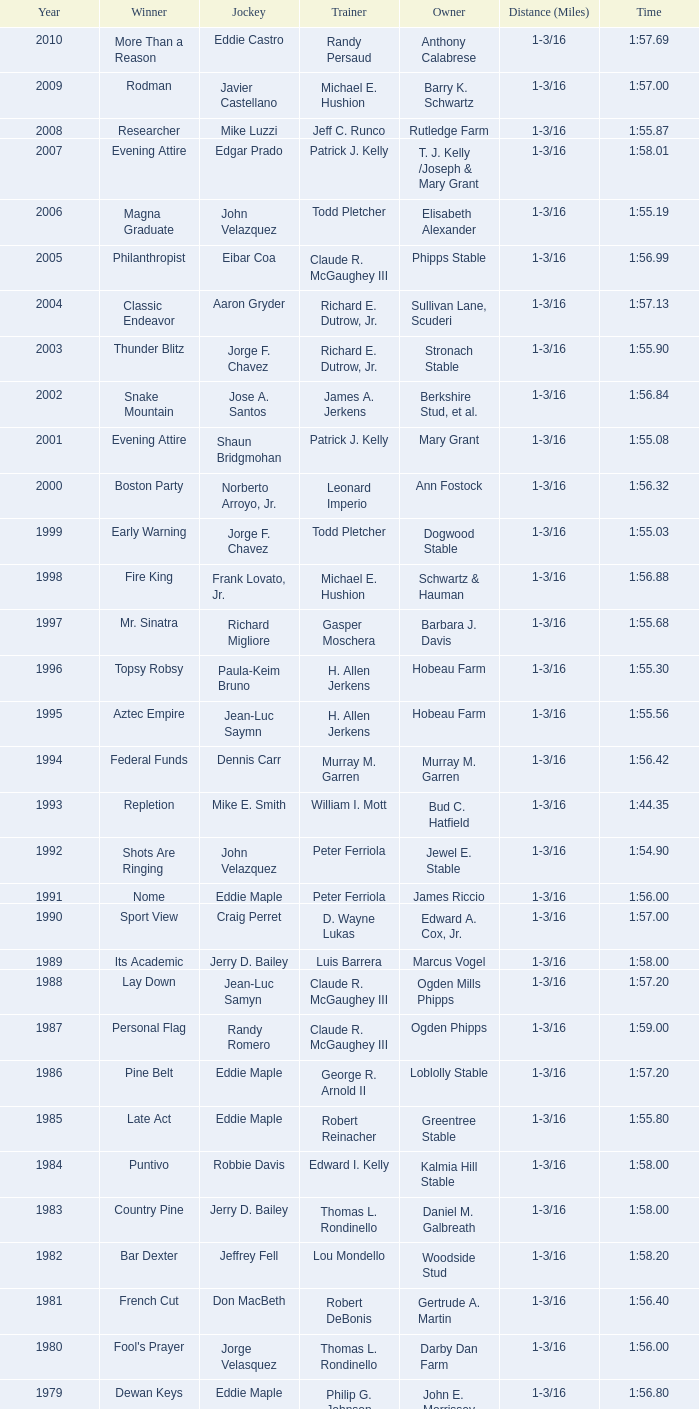What horse won with a trainer of "no race"? No Race, No Race, No Race, No Race. 